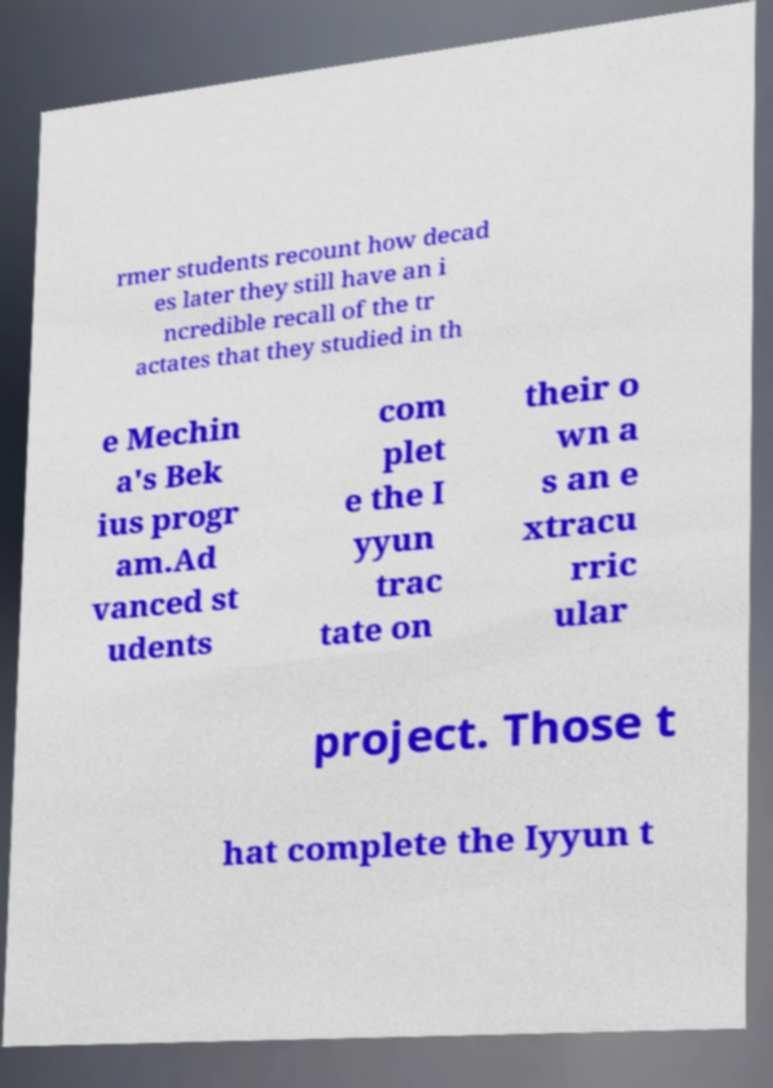Could you extract and type out the text from this image? rmer students recount how decad es later they still have an i ncredible recall of the tr actates that they studied in th e Mechin a's Bek ius progr am.Ad vanced st udents com plet e the I yyun trac tate on their o wn a s an e xtracu rric ular project. Those t hat complete the Iyyun t 